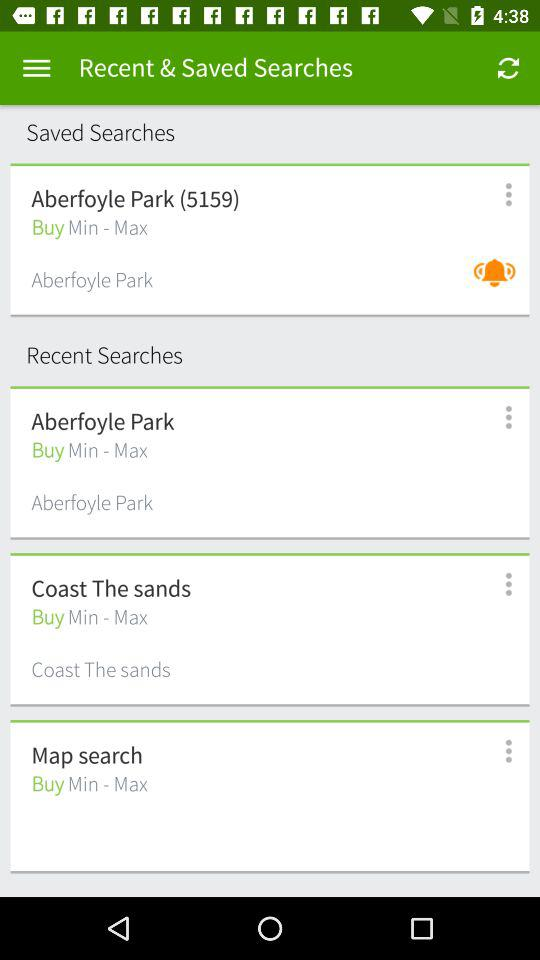How many more recent searches are there than saved searches?
Answer the question using a single word or phrase. 2 